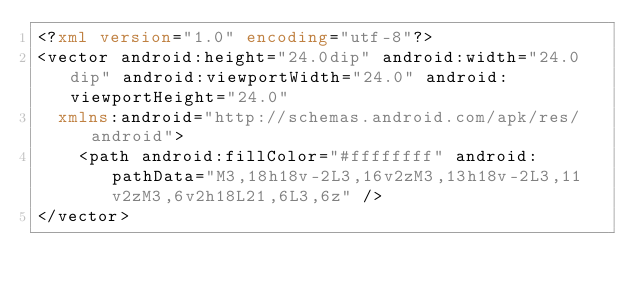Convert code to text. <code><loc_0><loc_0><loc_500><loc_500><_XML_><?xml version="1.0" encoding="utf-8"?>
<vector android:height="24.0dip" android:width="24.0dip" android:viewportWidth="24.0" android:viewportHeight="24.0"
  xmlns:android="http://schemas.android.com/apk/res/android">
    <path android:fillColor="#ffffffff" android:pathData="M3,18h18v-2L3,16v2zM3,13h18v-2L3,11v2zM3,6v2h18L21,6L3,6z" />
</vector>
</code> 